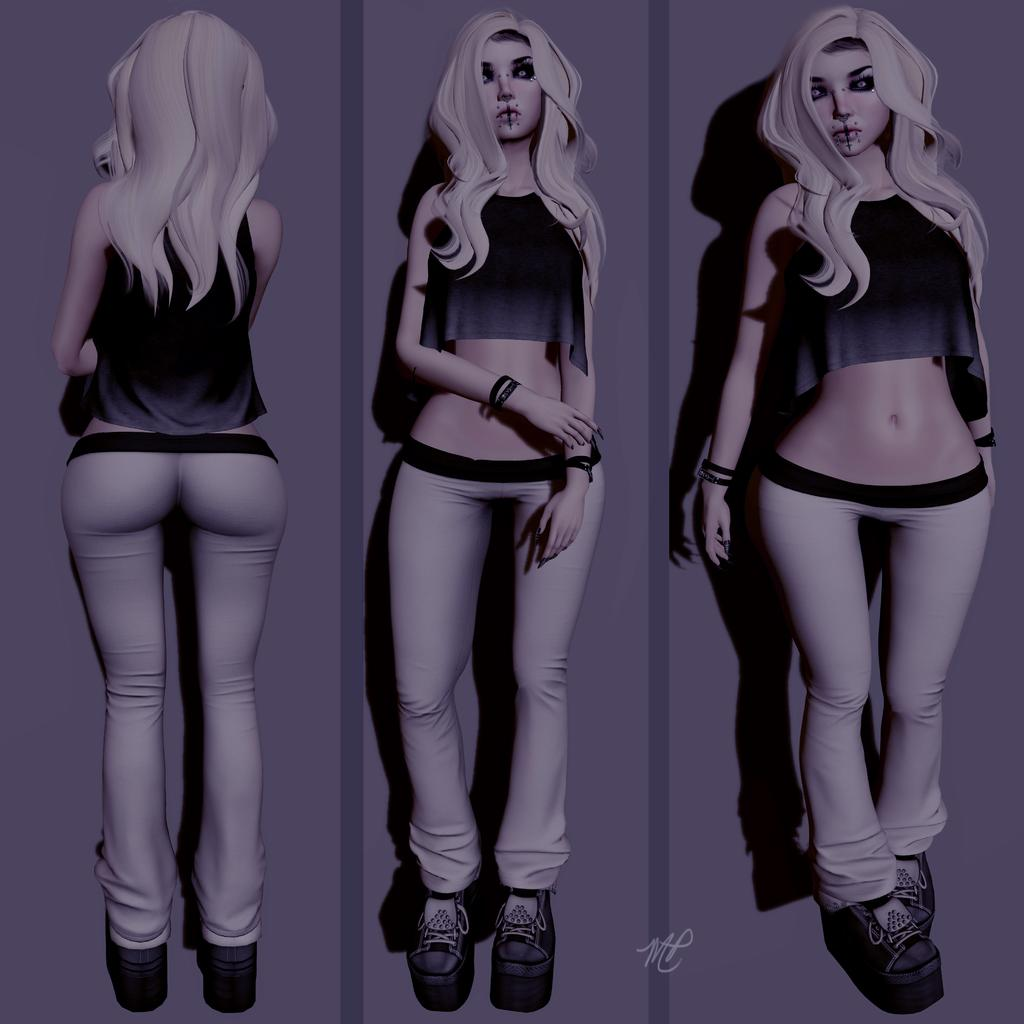What type of image is being described? The image is an animated picture. Can you describe any characters or figures in the image? There is a woman present in the image. How many times does the woman appear in the animated picture? The woman appears in three different images within the animated picture. What type of patch does the monkey have on its arm in the image? There is no monkey present in the image, so it is not possible to answer that question. 